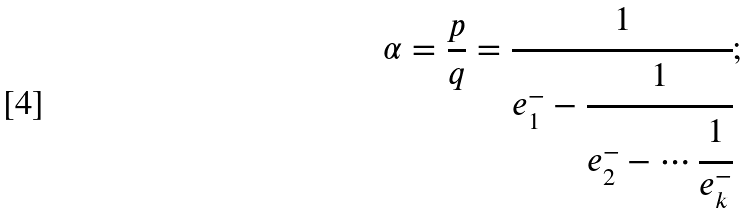<formula> <loc_0><loc_0><loc_500><loc_500>\alpha = \frac { p } { q } = \cfrac { 1 } { e ^ { - } _ { 1 } - \cfrac { 1 } { e ^ { - } _ { 2 } - \cdots \cfrac { 1 } { e ^ { - } _ { k } } } } ;</formula> 